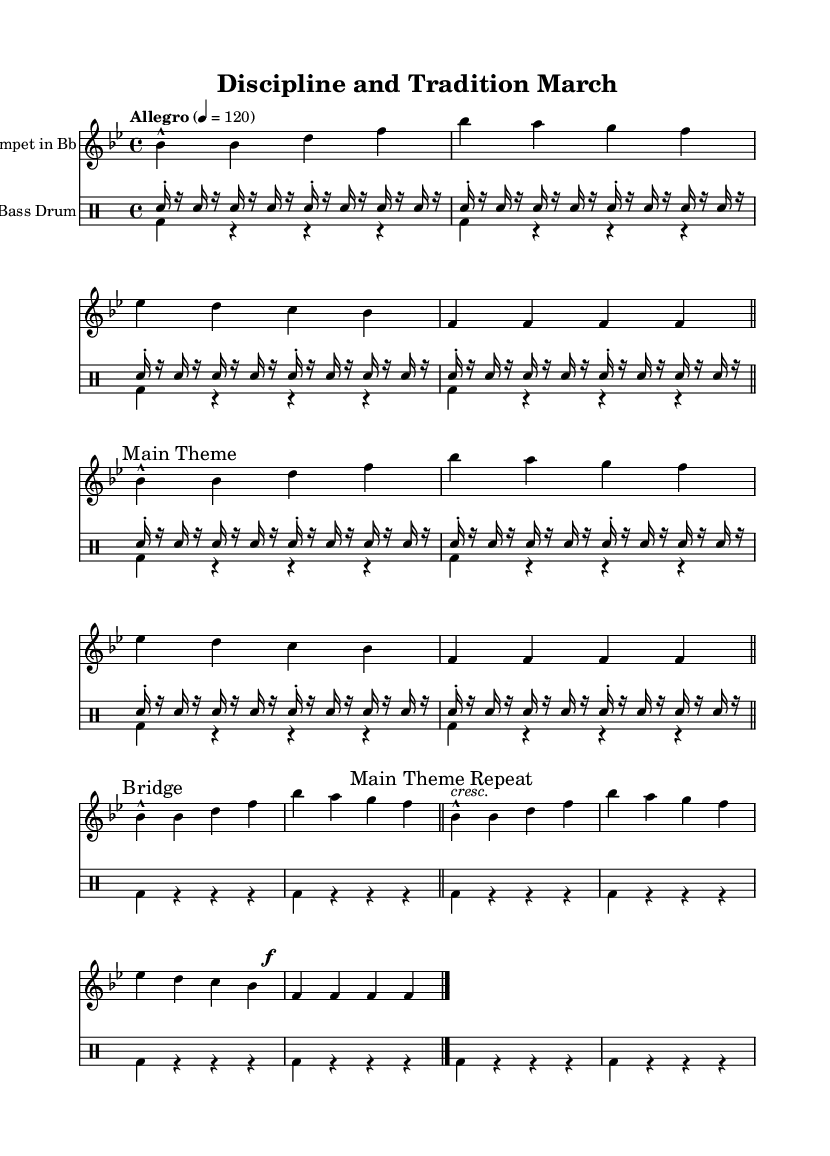What is the key signature of this music? The key signature is indicated by the number of flats or sharps at the beginning of the staff. In this case, there are two flats, which corresponds to B flat major.
Answer: B flat major What is the time signature of this piece? The time signature appears at the beginning of the staff, represented as a fraction showing how many beats are in a measure and what note value gets the beat. Here, it is 4 over 4, meaning there are four beats per measure.
Answer: 4/4 What is the tempo marking of the piece? The tempo marking is typically notated with a word or phrase, followed by a number. In this score, it is indicated as "Allegro" with a tempo of 120 beats per minute, signifying a fast pace.
Answer: Allegro 4 = 120 How many times is the "Main Theme" played in this piece? The "Main Theme" is marked twice in the score, first as the first section and again when it is repeated. Each instance indicates it is part of the composition.
Answer: 2 What rhythmic pattern does the snare drum follow? The snare drum part consists of sixteenth notes, marked with "sn16," and is structured in a repetitive pattern throughout the music. It maintains a steady rhythm, alternating between snare hits and rests.
Answer: Sixteenth notes What section follows the "Bridge" in the music? After the "Bridge" section, the score indicates a "Main Theme Repeat." This suggests the return of the initial theme, following the contrasting bridge segment.
Answer: Main Theme Repeat 